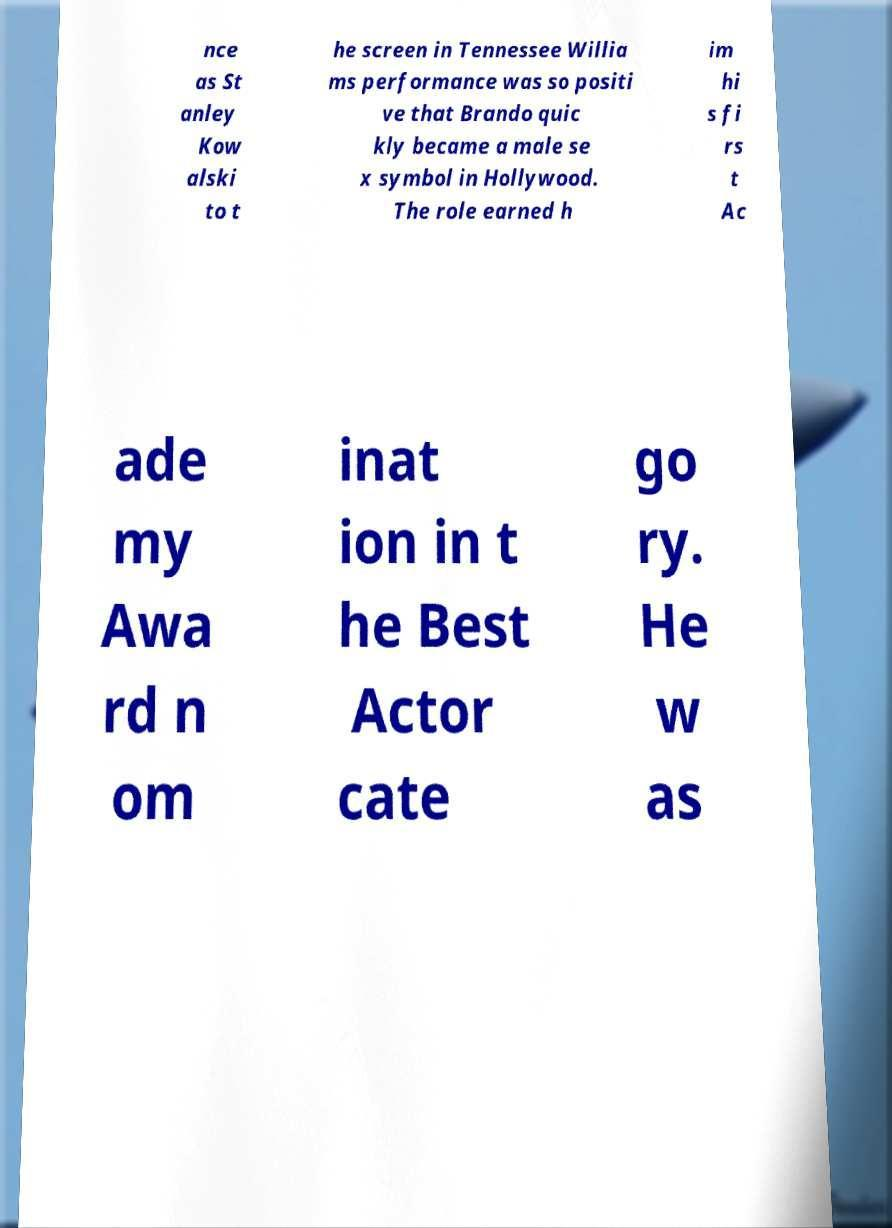Please read and relay the text visible in this image. What does it say? nce as St anley Kow alski to t he screen in Tennessee Willia ms performance was so positi ve that Brando quic kly became a male se x symbol in Hollywood. The role earned h im hi s fi rs t Ac ade my Awa rd n om inat ion in t he Best Actor cate go ry. He w as 